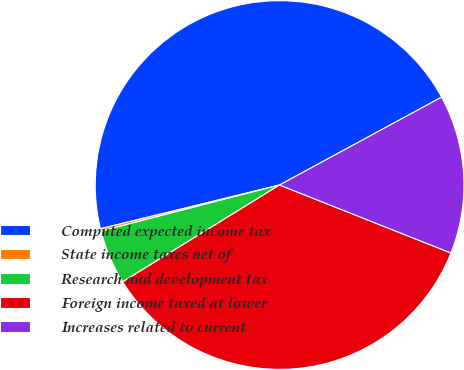<chart> <loc_0><loc_0><loc_500><loc_500><pie_chart><fcel>Computed expected income tax<fcel>State income taxes net of<fcel>Research and development tax<fcel>Foreign income taxed at lower<fcel>Increases related to current<nl><fcel>45.91%<fcel>0.21%<fcel>4.78%<fcel>35.19%<fcel>13.92%<nl></chart> 